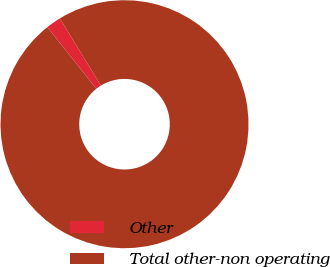<chart> <loc_0><loc_0><loc_500><loc_500><pie_chart><fcel>Other<fcel>Total other-non operating<nl><fcel>1.96%<fcel>98.04%<nl></chart> 